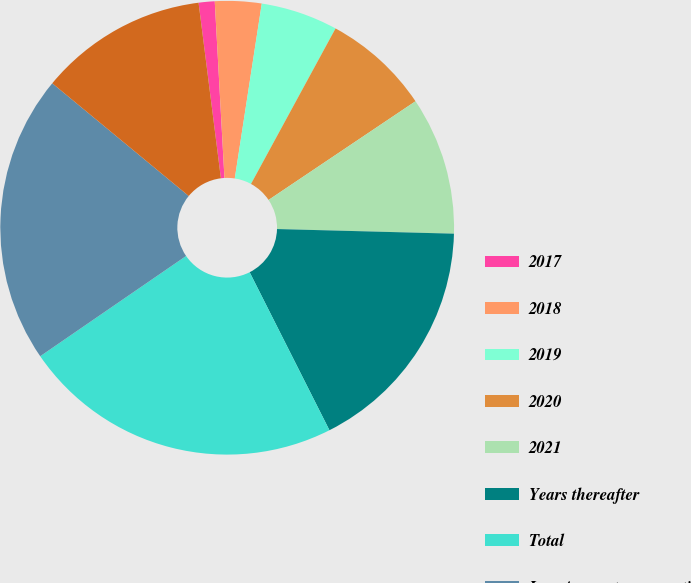Convert chart. <chart><loc_0><loc_0><loc_500><loc_500><pie_chart><fcel>2017<fcel>2018<fcel>2019<fcel>2020<fcel>2021<fcel>Years thereafter<fcel>Total<fcel>Less Amount representing<fcel>Present value of net minimum<nl><fcel>1.14%<fcel>3.31%<fcel>5.49%<fcel>7.66%<fcel>9.83%<fcel>17.14%<fcel>22.86%<fcel>20.57%<fcel>12.0%<nl></chart> 